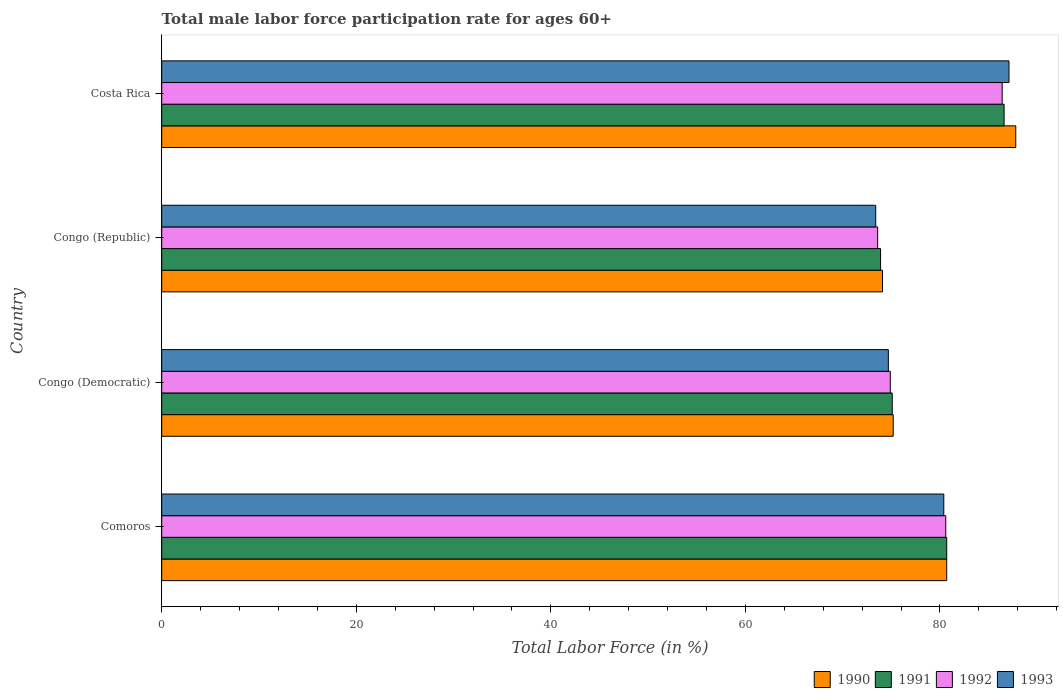How many different coloured bars are there?
Offer a terse response. 4. How many bars are there on the 1st tick from the top?
Offer a terse response. 4. What is the male labor force participation rate in 1991 in Comoros?
Make the answer very short. 80.7. Across all countries, what is the maximum male labor force participation rate in 1991?
Ensure brevity in your answer.  86.6. Across all countries, what is the minimum male labor force participation rate in 1993?
Make the answer very short. 73.4. In which country was the male labor force participation rate in 1990 maximum?
Make the answer very short. Costa Rica. In which country was the male labor force participation rate in 1992 minimum?
Make the answer very short. Congo (Republic). What is the total male labor force participation rate in 1990 in the graph?
Ensure brevity in your answer.  317.8. What is the difference between the male labor force participation rate in 1993 in Congo (Democratic) and that in Costa Rica?
Offer a terse response. -12.4. What is the difference between the male labor force participation rate in 1990 in Congo (Democratic) and the male labor force participation rate in 1993 in Congo (Republic)?
Ensure brevity in your answer.  1.8. What is the average male labor force participation rate in 1992 per country?
Provide a short and direct response. 78.87. What is the difference between the male labor force participation rate in 1993 and male labor force participation rate in 1991 in Comoros?
Provide a short and direct response. -0.3. What is the ratio of the male labor force participation rate in 1993 in Congo (Democratic) to that in Congo (Republic)?
Provide a short and direct response. 1.02. Is the male labor force participation rate in 1991 in Congo (Democratic) less than that in Costa Rica?
Give a very brief answer. Yes. Is the difference between the male labor force participation rate in 1993 in Congo (Democratic) and Costa Rica greater than the difference between the male labor force participation rate in 1991 in Congo (Democratic) and Costa Rica?
Make the answer very short. No. What is the difference between the highest and the second highest male labor force participation rate in 1992?
Your answer should be compact. 5.8. What is the difference between the highest and the lowest male labor force participation rate in 1993?
Make the answer very short. 13.7. Is the sum of the male labor force participation rate in 1992 in Comoros and Congo (Democratic) greater than the maximum male labor force participation rate in 1991 across all countries?
Your answer should be compact. Yes. Is it the case that in every country, the sum of the male labor force participation rate in 1992 and male labor force participation rate in 1991 is greater than the sum of male labor force participation rate in 1990 and male labor force participation rate in 1993?
Keep it short and to the point. No. What does the 3rd bar from the top in Costa Rica represents?
Ensure brevity in your answer.  1991. What does the 3rd bar from the bottom in Comoros represents?
Make the answer very short. 1992. Is it the case that in every country, the sum of the male labor force participation rate in 1990 and male labor force participation rate in 1993 is greater than the male labor force participation rate in 1991?
Your answer should be compact. Yes. How many bars are there?
Your answer should be very brief. 16. Are all the bars in the graph horizontal?
Provide a succinct answer. Yes. What is the difference between two consecutive major ticks on the X-axis?
Keep it short and to the point. 20. Are the values on the major ticks of X-axis written in scientific E-notation?
Provide a short and direct response. No. Does the graph contain grids?
Ensure brevity in your answer.  No. How many legend labels are there?
Ensure brevity in your answer.  4. What is the title of the graph?
Offer a very short reply. Total male labor force participation rate for ages 60+. Does "1983" appear as one of the legend labels in the graph?
Offer a terse response. No. What is the Total Labor Force (in %) in 1990 in Comoros?
Your response must be concise. 80.7. What is the Total Labor Force (in %) of 1991 in Comoros?
Your answer should be compact. 80.7. What is the Total Labor Force (in %) of 1992 in Comoros?
Offer a very short reply. 80.6. What is the Total Labor Force (in %) in 1993 in Comoros?
Provide a succinct answer. 80.4. What is the Total Labor Force (in %) in 1990 in Congo (Democratic)?
Your response must be concise. 75.2. What is the Total Labor Force (in %) of 1991 in Congo (Democratic)?
Offer a very short reply. 75.1. What is the Total Labor Force (in %) of 1992 in Congo (Democratic)?
Offer a terse response. 74.9. What is the Total Labor Force (in %) in 1993 in Congo (Democratic)?
Your answer should be compact. 74.7. What is the Total Labor Force (in %) of 1990 in Congo (Republic)?
Offer a very short reply. 74.1. What is the Total Labor Force (in %) in 1991 in Congo (Republic)?
Make the answer very short. 73.9. What is the Total Labor Force (in %) in 1992 in Congo (Republic)?
Your answer should be very brief. 73.6. What is the Total Labor Force (in %) of 1993 in Congo (Republic)?
Offer a terse response. 73.4. What is the Total Labor Force (in %) of 1990 in Costa Rica?
Your answer should be very brief. 87.8. What is the Total Labor Force (in %) of 1991 in Costa Rica?
Your response must be concise. 86.6. What is the Total Labor Force (in %) of 1992 in Costa Rica?
Your answer should be very brief. 86.4. What is the Total Labor Force (in %) in 1993 in Costa Rica?
Keep it short and to the point. 87.1. Across all countries, what is the maximum Total Labor Force (in %) in 1990?
Make the answer very short. 87.8. Across all countries, what is the maximum Total Labor Force (in %) of 1991?
Keep it short and to the point. 86.6. Across all countries, what is the maximum Total Labor Force (in %) of 1992?
Give a very brief answer. 86.4. Across all countries, what is the maximum Total Labor Force (in %) of 1993?
Your answer should be very brief. 87.1. Across all countries, what is the minimum Total Labor Force (in %) of 1990?
Give a very brief answer. 74.1. Across all countries, what is the minimum Total Labor Force (in %) in 1991?
Make the answer very short. 73.9. Across all countries, what is the minimum Total Labor Force (in %) of 1992?
Make the answer very short. 73.6. Across all countries, what is the minimum Total Labor Force (in %) of 1993?
Your answer should be very brief. 73.4. What is the total Total Labor Force (in %) in 1990 in the graph?
Make the answer very short. 317.8. What is the total Total Labor Force (in %) in 1991 in the graph?
Provide a short and direct response. 316.3. What is the total Total Labor Force (in %) of 1992 in the graph?
Offer a very short reply. 315.5. What is the total Total Labor Force (in %) of 1993 in the graph?
Give a very brief answer. 315.6. What is the difference between the Total Labor Force (in %) in 1990 in Comoros and that in Congo (Democratic)?
Offer a terse response. 5.5. What is the difference between the Total Labor Force (in %) in 1991 in Comoros and that in Congo (Democratic)?
Offer a very short reply. 5.6. What is the difference between the Total Labor Force (in %) in 1992 in Comoros and that in Congo (Democratic)?
Offer a very short reply. 5.7. What is the difference between the Total Labor Force (in %) in 1990 in Comoros and that in Congo (Republic)?
Your answer should be compact. 6.6. What is the difference between the Total Labor Force (in %) of 1993 in Comoros and that in Congo (Republic)?
Offer a very short reply. 7. What is the difference between the Total Labor Force (in %) in 1990 in Comoros and that in Costa Rica?
Keep it short and to the point. -7.1. What is the difference between the Total Labor Force (in %) in 1993 in Comoros and that in Costa Rica?
Ensure brevity in your answer.  -6.7. What is the difference between the Total Labor Force (in %) in 1990 in Congo (Democratic) and that in Congo (Republic)?
Ensure brevity in your answer.  1.1. What is the difference between the Total Labor Force (in %) of 1992 in Congo (Democratic) and that in Congo (Republic)?
Ensure brevity in your answer.  1.3. What is the difference between the Total Labor Force (in %) in 1993 in Congo (Democratic) and that in Congo (Republic)?
Provide a short and direct response. 1.3. What is the difference between the Total Labor Force (in %) in 1990 in Congo (Democratic) and that in Costa Rica?
Offer a very short reply. -12.6. What is the difference between the Total Labor Force (in %) in 1990 in Congo (Republic) and that in Costa Rica?
Offer a very short reply. -13.7. What is the difference between the Total Labor Force (in %) in 1993 in Congo (Republic) and that in Costa Rica?
Your answer should be compact. -13.7. What is the difference between the Total Labor Force (in %) of 1990 in Comoros and the Total Labor Force (in %) of 1992 in Congo (Republic)?
Offer a terse response. 7.1. What is the difference between the Total Labor Force (in %) of 1990 in Comoros and the Total Labor Force (in %) of 1993 in Congo (Republic)?
Your answer should be compact. 7.3. What is the difference between the Total Labor Force (in %) of 1991 in Comoros and the Total Labor Force (in %) of 1993 in Congo (Republic)?
Make the answer very short. 7.3. What is the difference between the Total Labor Force (in %) in 1992 in Comoros and the Total Labor Force (in %) in 1993 in Congo (Republic)?
Make the answer very short. 7.2. What is the difference between the Total Labor Force (in %) of 1990 in Comoros and the Total Labor Force (in %) of 1993 in Costa Rica?
Ensure brevity in your answer.  -6.4. What is the difference between the Total Labor Force (in %) in 1991 in Comoros and the Total Labor Force (in %) in 1993 in Costa Rica?
Provide a succinct answer. -6.4. What is the difference between the Total Labor Force (in %) of 1990 in Congo (Democratic) and the Total Labor Force (in %) of 1992 in Congo (Republic)?
Provide a short and direct response. 1.6. What is the difference between the Total Labor Force (in %) of 1991 in Congo (Democratic) and the Total Labor Force (in %) of 1992 in Congo (Republic)?
Ensure brevity in your answer.  1.5. What is the difference between the Total Labor Force (in %) of 1991 in Congo (Democratic) and the Total Labor Force (in %) of 1993 in Congo (Republic)?
Provide a short and direct response. 1.7. What is the difference between the Total Labor Force (in %) in 1990 in Congo (Democratic) and the Total Labor Force (in %) in 1992 in Costa Rica?
Keep it short and to the point. -11.2. What is the difference between the Total Labor Force (in %) of 1990 in Congo (Democratic) and the Total Labor Force (in %) of 1993 in Costa Rica?
Offer a very short reply. -11.9. What is the difference between the Total Labor Force (in %) of 1991 in Congo (Democratic) and the Total Labor Force (in %) of 1992 in Costa Rica?
Give a very brief answer. -11.3. What is the difference between the Total Labor Force (in %) in 1991 in Congo (Democratic) and the Total Labor Force (in %) in 1993 in Costa Rica?
Keep it short and to the point. -12. What is the difference between the Total Labor Force (in %) in 1992 in Congo (Democratic) and the Total Labor Force (in %) in 1993 in Costa Rica?
Keep it short and to the point. -12.2. What is the difference between the Total Labor Force (in %) of 1990 in Congo (Republic) and the Total Labor Force (in %) of 1991 in Costa Rica?
Provide a short and direct response. -12.5. What is the difference between the Total Labor Force (in %) of 1991 in Congo (Republic) and the Total Labor Force (in %) of 1992 in Costa Rica?
Give a very brief answer. -12.5. What is the difference between the Total Labor Force (in %) in 1992 in Congo (Republic) and the Total Labor Force (in %) in 1993 in Costa Rica?
Offer a very short reply. -13.5. What is the average Total Labor Force (in %) in 1990 per country?
Ensure brevity in your answer.  79.45. What is the average Total Labor Force (in %) in 1991 per country?
Give a very brief answer. 79.08. What is the average Total Labor Force (in %) of 1992 per country?
Keep it short and to the point. 78.88. What is the average Total Labor Force (in %) in 1993 per country?
Offer a terse response. 78.9. What is the difference between the Total Labor Force (in %) of 1990 and Total Labor Force (in %) of 1991 in Comoros?
Your response must be concise. 0. What is the difference between the Total Labor Force (in %) of 1991 and Total Labor Force (in %) of 1992 in Comoros?
Keep it short and to the point. 0.1. What is the difference between the Total Labor Force (in %) in 1990 and Total Labor Force (in %) in 1992 in Congo (Democratic)?
Your answer should be compact. 0.3. What is the difference between the Total Labor Force (in %) in 1990 and Total Labor Force (in %) in 1993 in Congo (Democratic)?
Your answer should be very brief. 0.5. What is the difference between the Total Labor Force (in %) in 1991 and Total Labor Force (in %) in 1992 in Congo (Democratic)?
Ensure brevity in your answer.  0.2. What is the difference between the Total Labor Force (in %) of 1990 and Total Labor Force (in %) of 1991 in Congo (Republic)?
Provide a succinct answer. 0.2. What is the difference between the Total Labor Force (in %) in 1990 and Total Labor Force (in %) in 1992 in Congo (Republic)?
Provide a short and direct response. 0.5. What is the difference between the Total Labor Force (in %) of 1991 and Total Labor Force (in %) of 1993 in Congo (Republic)?
Your answer should be very brief. 0.5. What is the difference between the Total Labor Force (in %) of 1990 and Total Labor Force (in %) of 1991 in Costa Rica?
Make the answer very short. 1.2. What is the difference between the Total Labor Force (in %) in 1991 and Total Labor Force (in %) in 1992 in Costa Rica?
Give a very brief answer. 0.2. What is the difference between the Total Labor Force (in %) in 1991 and Total Labor Force (in %) in 1993 in Costa Rica?
Provide a short and direct response. -0.5. What is the difference between the Total Labor Force (in %) of 1992 and Total Labor Force (in %) of 1993 in Costa Rica?
Ensure brevity in your answer.  -0.7. What is the ratio of the Total Labor Force (in %) of 1990 in Comoros to that in Congo (Democratic)?
Your answer should be compact. 1.07. What is the ratio of the Total Labor Force (in %) of 1991 in Comoros to that in Congo (Democratic)?
Offer a very short reply. 1.07. What is the ratio of the Total Labor Force (in %) in 1992 in Comoros to that in Congo (Democratic)?
Your answer should be compact. 1.08. What is the ratio of the Total Labor Force (in %) of 1993 in Comoros to that in Congo (Democratic)?
Provide a short and direct response. 1.08. What is the ratio of the Total Labor Force (in %) in 1990 in Comoros to that in Congo (Republic)?
Keep it short and to the point. 1.09. What is the ratio of the Total Labor Force (in %) of 1991 in Comoros to that in Congo (Republic)?
Offer a terse response. 1.09. What is the ratio of the Total Labor Force (in %) in 1992 in Comoros to that in Congo (Republic)?
Offer a terse response. 1.1. What is the ratio of the Total Labor Force (in %) of 1993 in Comoros to that in Congo (Republic)?
Offer a very short reply. 1.1. What is the ratio of the Total Labor Force (in %) in 1990 in Comoros to that in Costa Rica?
Offer a very short reply. 0.92. What is the ratio of the Total Labor Force (in %) in 1991 in Comoros to that in Costa Rica?
Keep it short and to the point. 0.93. What is the ratio of the Total Labor Force (in %) in 1992 in Comoros to that in Costa Rica?
Ensure brevity in your answer.  0.93. What is the ratio of the Total Labor Force (in %) of 1993 in Comoros to that in Costa Rica?
Keep it short and to the point. 0.92. What is the ratio of the Total Labor Force (in %) of 1990 in Congo (Democratic) to that in Congo (Republic)?
Give a very brief answer. 1.01. What is the ratio of the Total Labor Force (in %) in 1991 in Congo (Democratic) to that in Congo (Republic)?
Provide a succinct answer. 1.02. What is the ratio of the Total Labor Force (in %) in 1992 in Congo (Democratic) to that in Congo (Republic)?
Provide a short and direct response. 1.02. What is the ratio of the Total Labor Force (in %) in 1993 in Congo (Democratic) to that in Congo (Republic)?
Your response must be concise. 1.02. What is the ratio of the Total Labor Force (in %) in 1990 in Congo (Democratic) to that in Costa Rica?
Keep it short and to the point. 0.86. What is the ratio of the Total Labor Force (in %) in 1991 in Congo (Democratic) to that in Costa Rica?
Provide a succinct answer. 0.87. What is the ratio of the Total Labor Force (in %) in 1992 in Congo (Democratic) to that in Costa Rica?
Provide a succinct answer. 0.87. What is the ratio of the Total Labor Force (in %) of 1993 in Congo (Democratic) to that in Costa Rica?
Make the answer very short. 0.86. What is the ratio of the Total Labor Force (in %) of 1990 in Congo (Republic) to that in Costa Rica?
Ensure brevity in your answer.  0.84. What is the ratio of the Total Labor Force (in %) of 1991 in Congo (Republic) to that in Costa Rica?
Your answer should be compact. 0.85. What is the ratio of the Total Labor Force (in %) in 1992 in Congo (Republic) to that in Costa Rica?
Keep it short and to the point. 0.85. What is the ratio of the Total Labor Force (in %) of 1993 in Congo (Republic) to that in Costa Rica?
Your answer should be very brief. 0.84. What is the difference between the highest and the lowest Total Labor Force (in %) of 1992?
Your answer should be very brief. 12.8. What is the difference between the highest and the lowest Total Labor Force (in %) in 1993?
Offer a terse response. 13.7. 